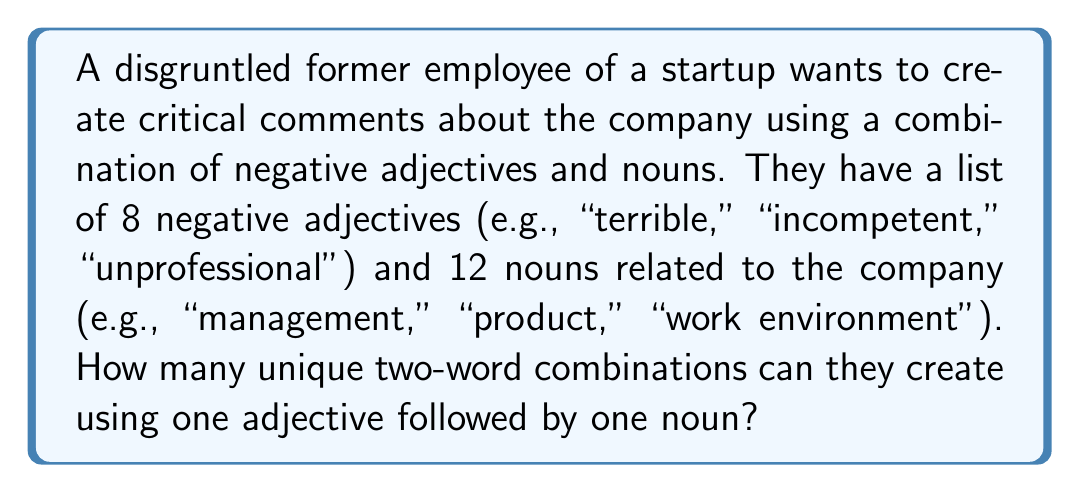Teach me how to tackle this problem. To solve this problem, we need to use the multiplication principle of counting. The disgruntled former employee is creating combinations where:

1. The first word is always an adjective
2. The second word is always a noun
3. Each combination consists of exactly one adjective and one noun

Let's break down the problem:

1. Number of ways to choose an adjective: 8
2. Number of ways to choose a noun: 12

According to the multiplication principle, when we have independent choices, we multiply the number of options for each choice.

Therefore, the total number of unique two-word combinations is:

$$ \text{Total combinations} = \text{Number of adjectives} \times \text{Number of nouns} $$

$$ \text{Total combinations} = 8 \times 12 $$

$$ \text{Total combinations} = 96 $$

This means the disgruntled former employee can create 96 unique two-word combinations to use in their critical comments about the startup.
Answer: 96 unique two-word combinations 